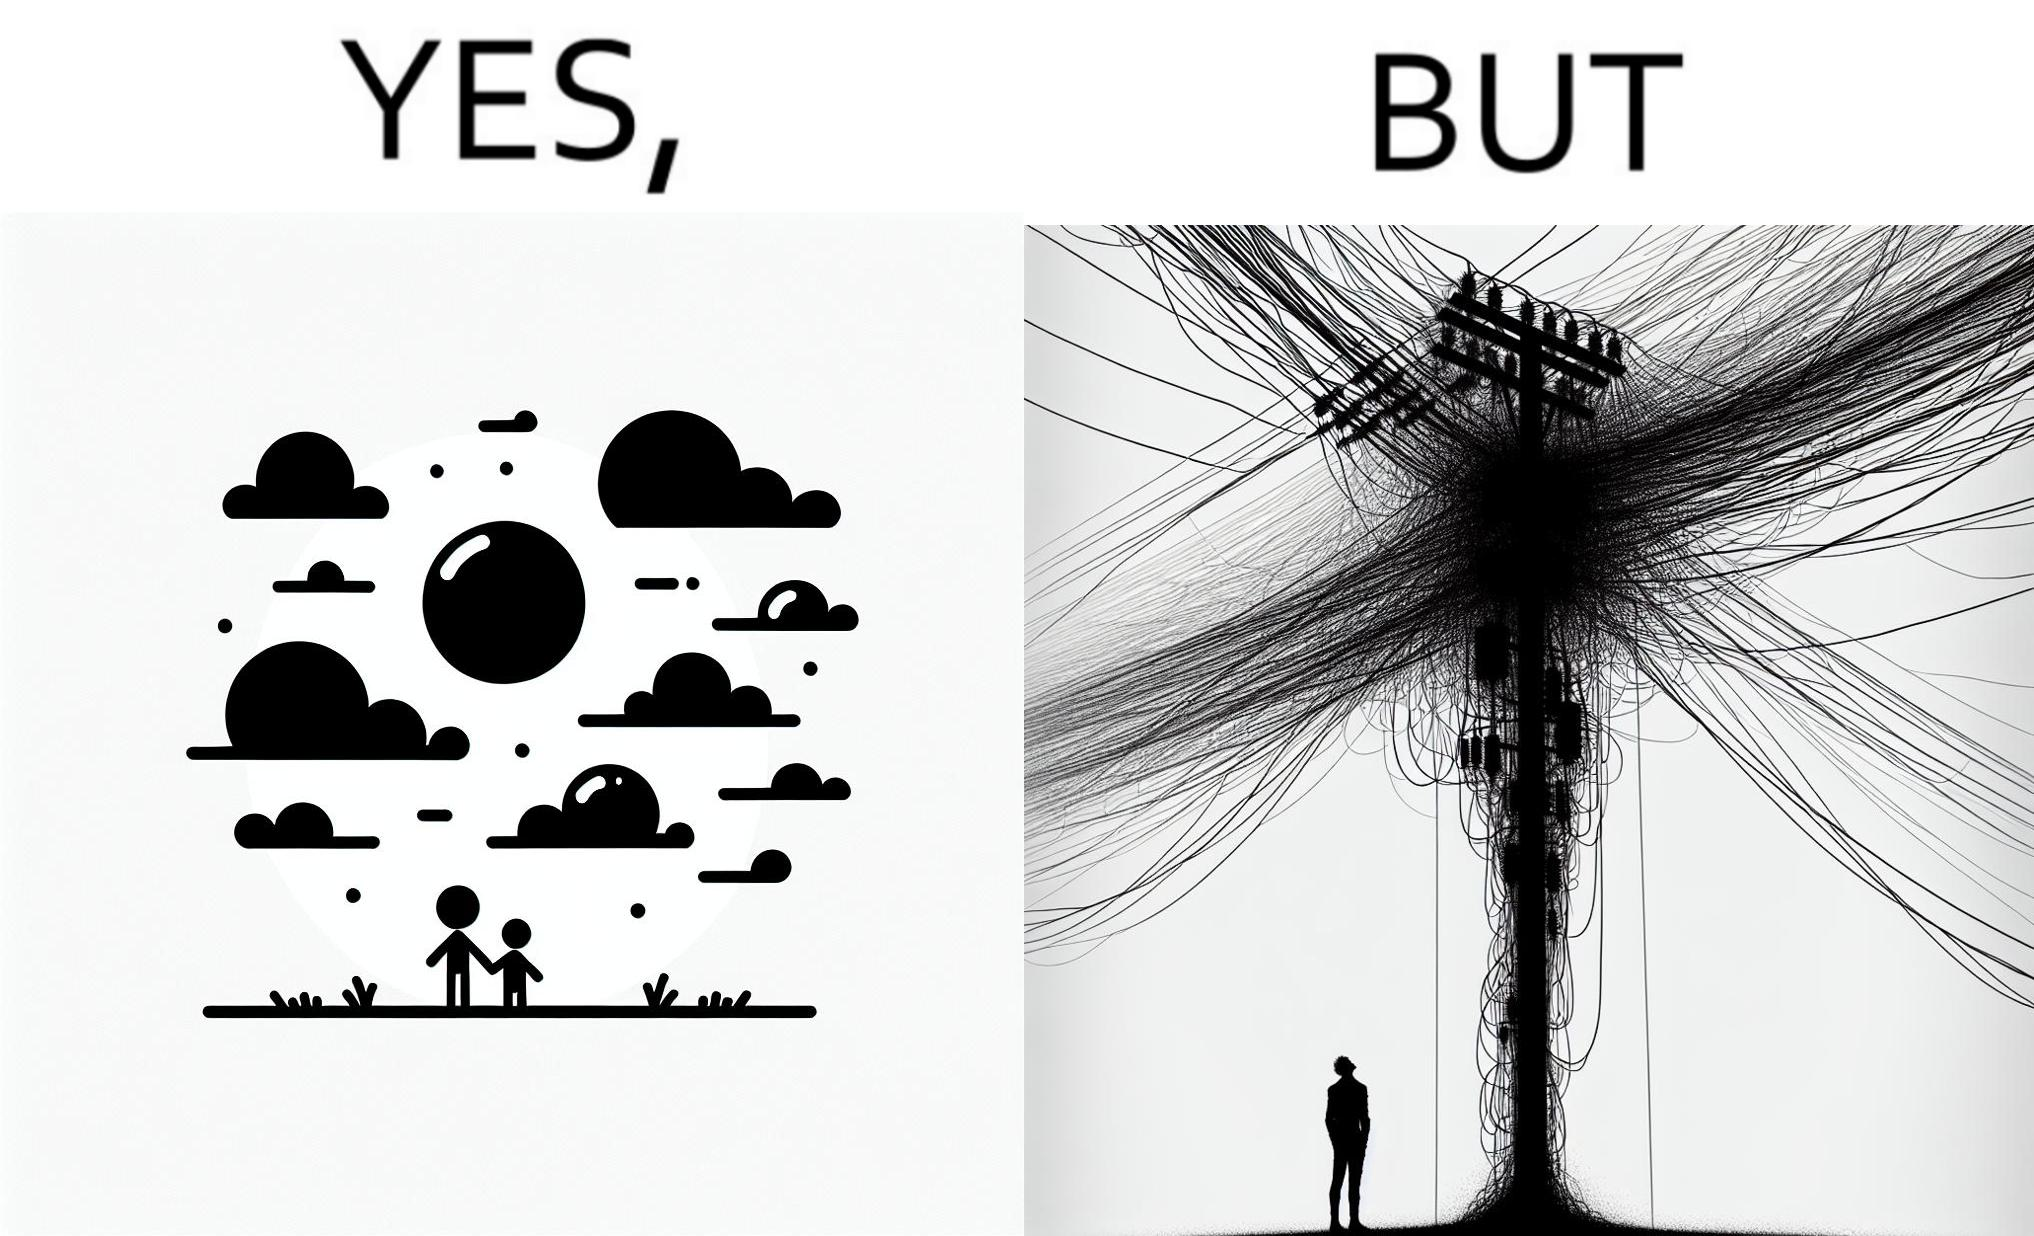What does this image depict? The image is ironic, because in the first image clear sky is visible but in the second image the same view is getting blocked due to the electricity pole 